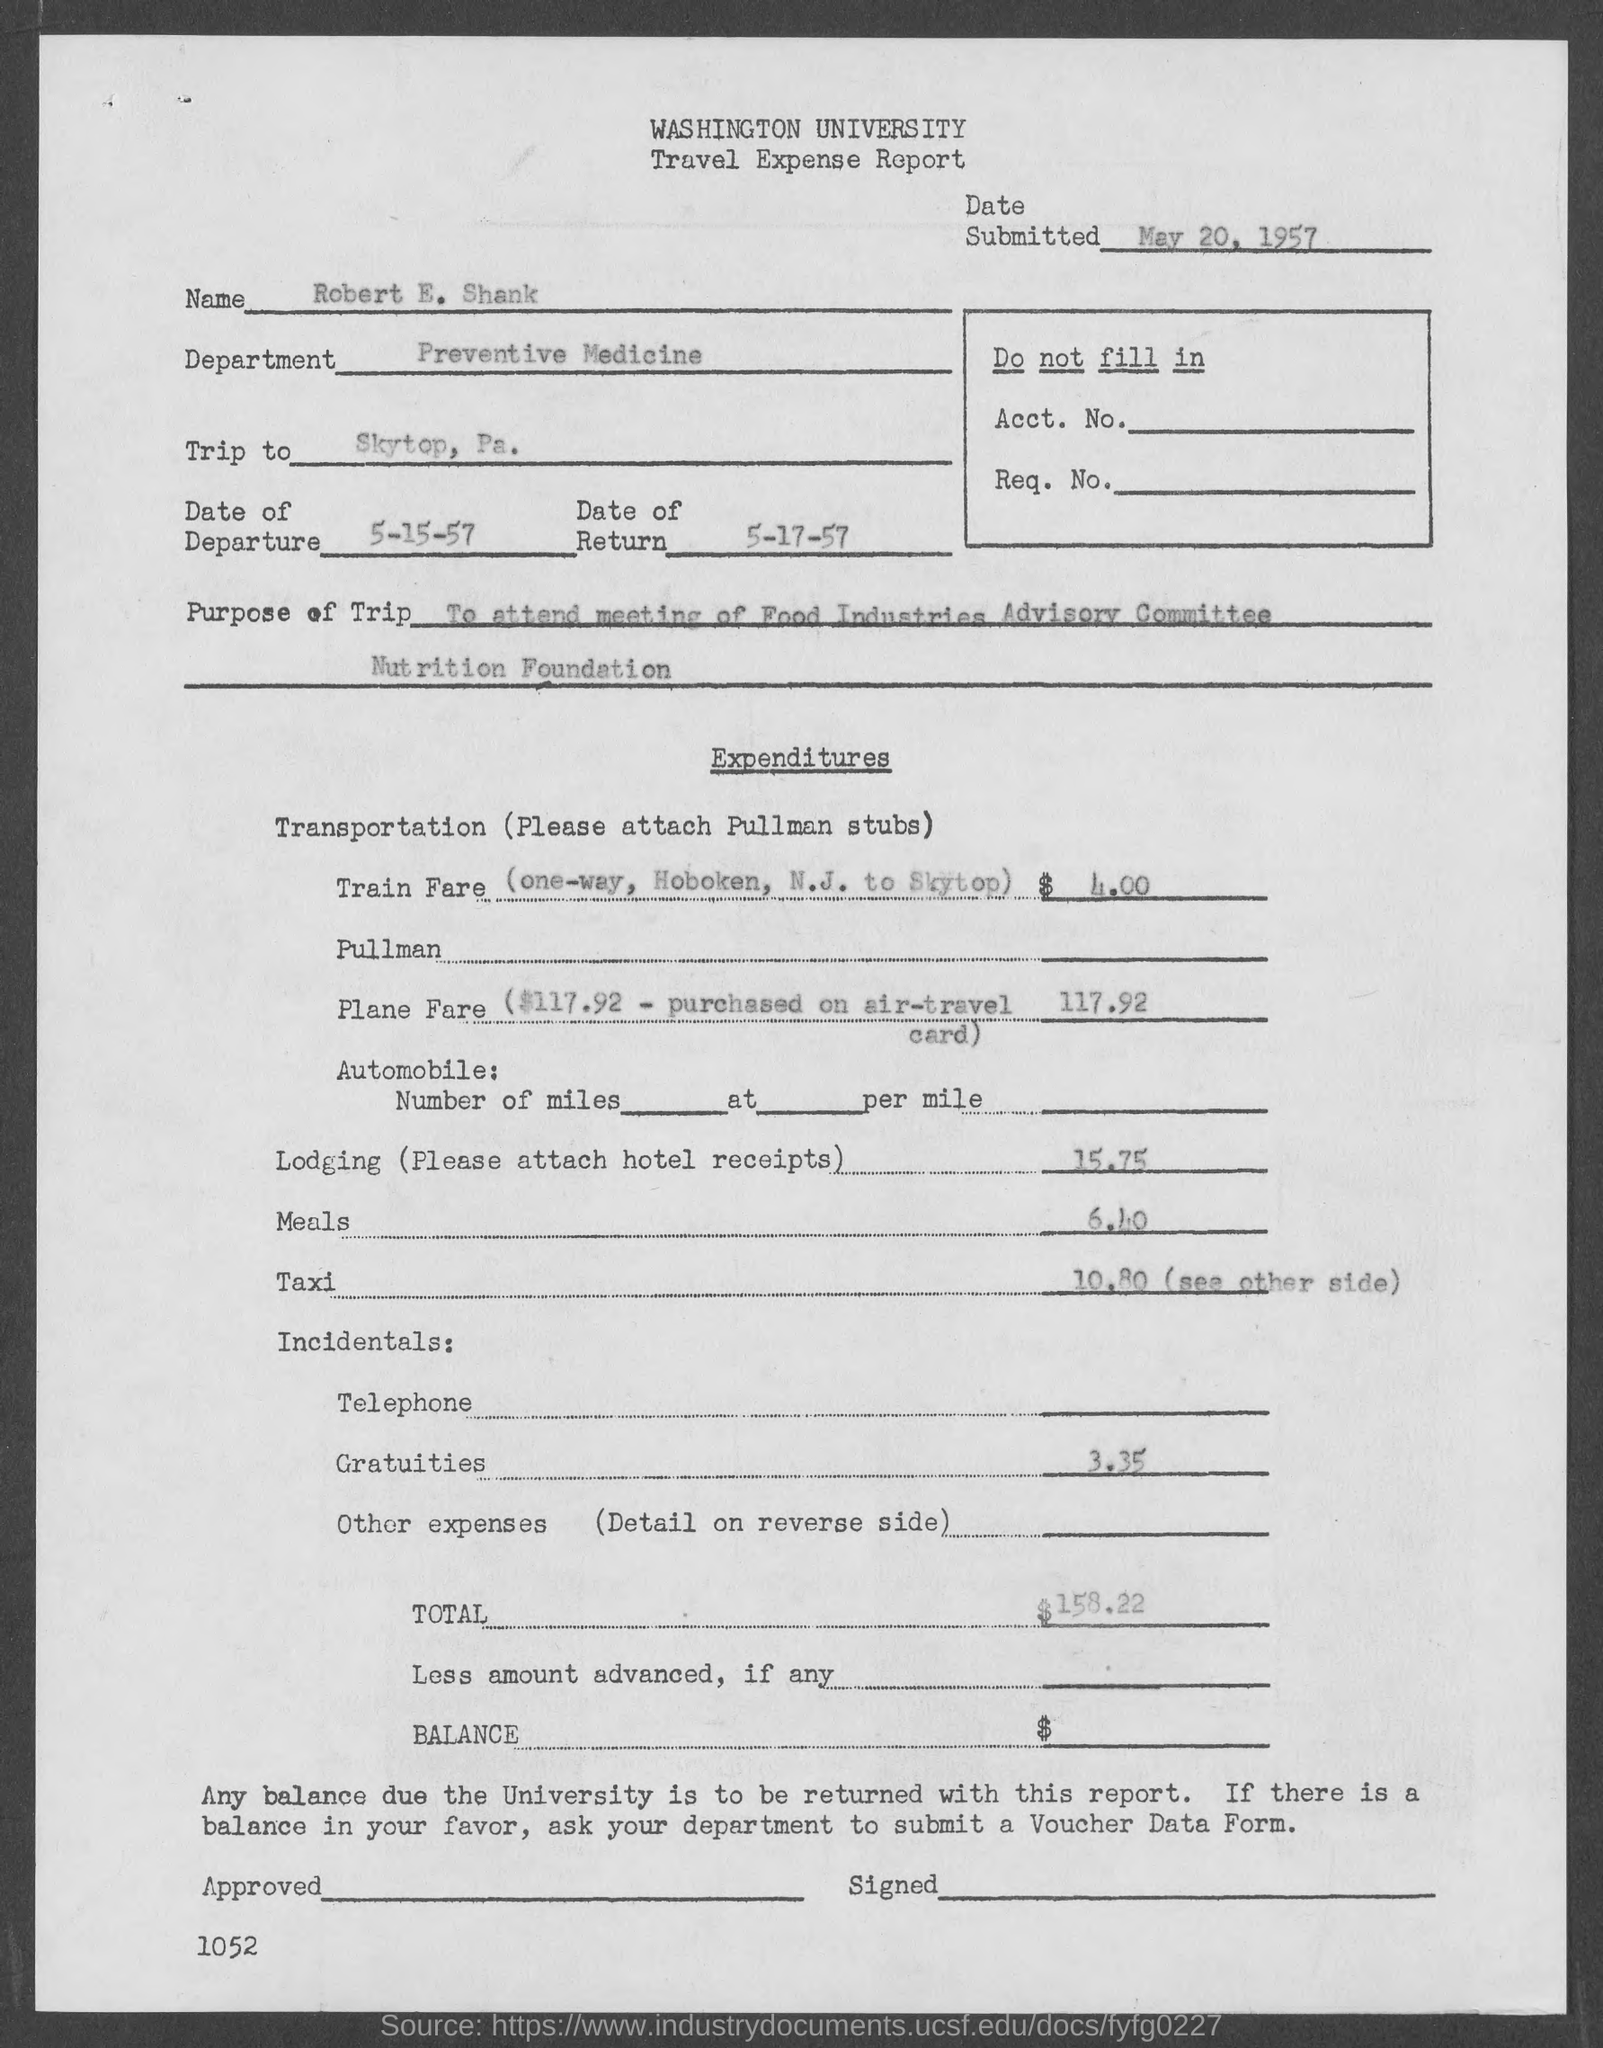Which university's travel expense report is given here?
Ensure brevity in your answer.  Washington University. What is the name mentioned in the travel expense report?
Keep it short and to the point. Robert E. Shank. In which department, Robert E. Shank works?
Your answer should be compact. Preventive Medicine. What is the date of departure given in the travel expense report?
Make the answer very short. 5-15-57. What is the date of return mentioned in the travel expense report?
Provide a short and direct response. 5-17-57. What is the Purpose of the trip mentioned in the report?
Your answer should be compact. To attend meeting of Food Industries Advisory Committee, Nutrition Foundation. What is the total travel expense mentioned in the document?
Provide a short and direct response. 158.22. What is the train fare expense mentioned in the document?
Provide a succinct answer. 4.00. 